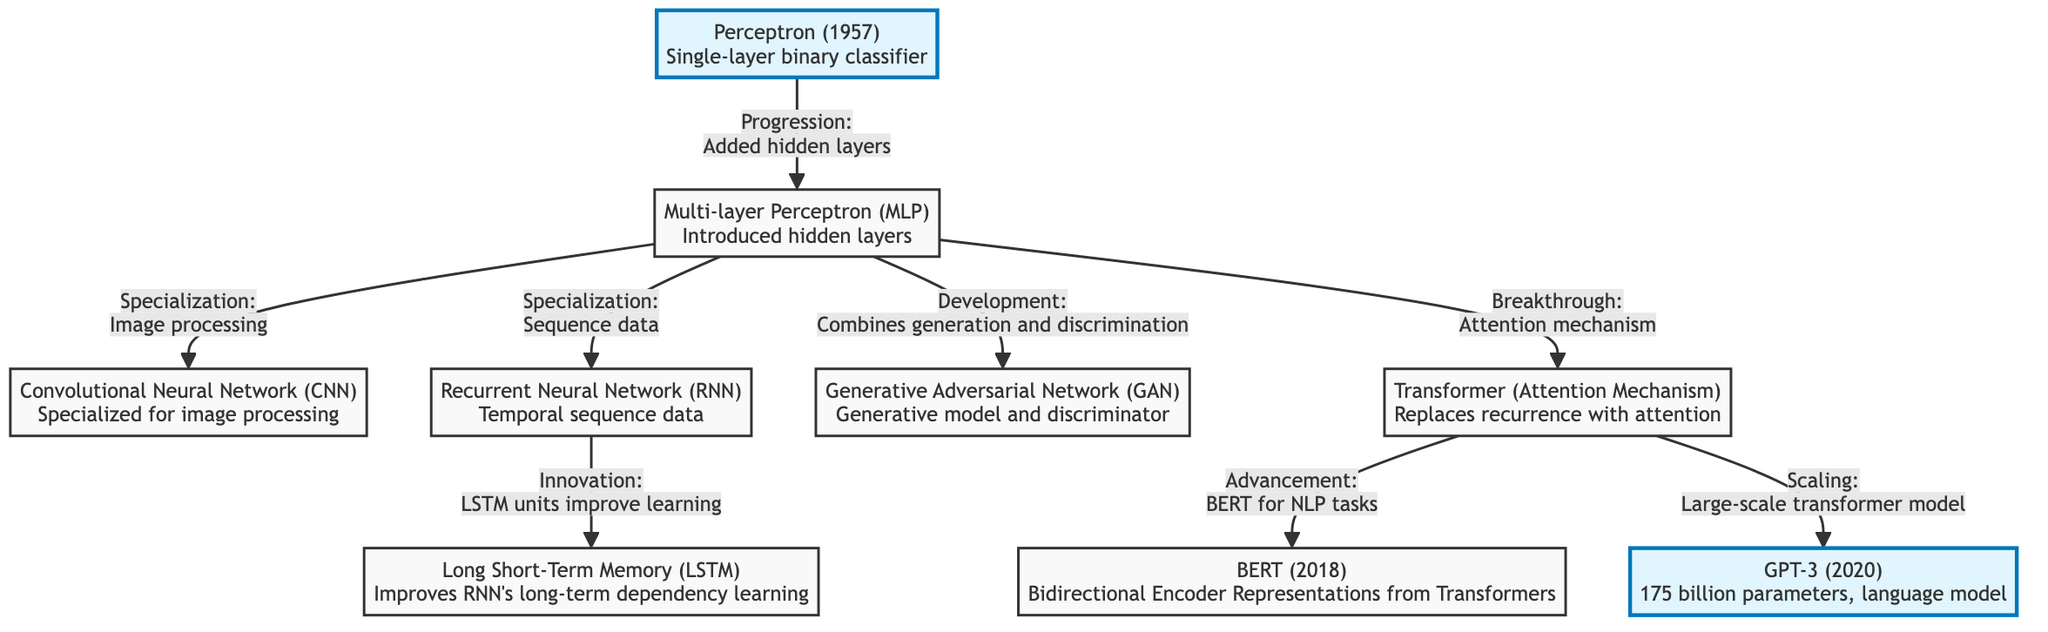What is the first architecture mentioned in the diagram? The first architecture is located at the top of the diagram. Following the flow chart from the top, the first node is labeled "Perceptron (1957) Single-layer binary classifier."
Answer: Perceptron (1957) How many architectures are listed in the diagram? By counting the nodes in the flowchart, there are a total of nine distinct neural network architectures represented.
Answer: Nine What technology introduced hidden layers? The arrow from the Perceptron node to the Multi-layer Perceptron node denotes the introduction of hidden layers in the architecture.
Answer: Multi-layer Perceptron Which model specializes in image processing? The diagram indicates a direct relationship from the Multi-layer Perceptron to the Convolutional Neural Network, suggesting that the CNN is specialized for image processing.
Answer: Convolutional Neural Network What follows after the Recurrent Neural Network in the diagram? By tracing the diagram from the Recurrent Neural Network node, the next node is labeled "Long Short-Term Memory," indicating an innovation built upon the RNN.
Answer: Long Short-Term Memory Which model employs an attention mechanism? The flow arrow connected to the Transformer indicates that it is the architecture that replaces recurrence with an attention mechanism.
Answer: Transformer How does the Long Short-Term Memory improve the capabilities of the RNN? The diagram highlights that the Long Short-Term Memory improves the Recurrent Neural Network's long-term dependency learning, indicating its enhanced capability.
Answer: Long-term dependency learning Which architecture is a generative model that includes a discriminator? The Generative Adversarial Network node in the diagram is explicitly noted as a generative model paired with a discriminator, indicating its architecture type.
Answer: Generative Adversarial Network What major breakthrough technology is connected to BERT? The arrow from the Transformer node to the BERT node indicates that BERT was developed as part of advancements in the attention mechanism.
Answer: Attention mechanism 